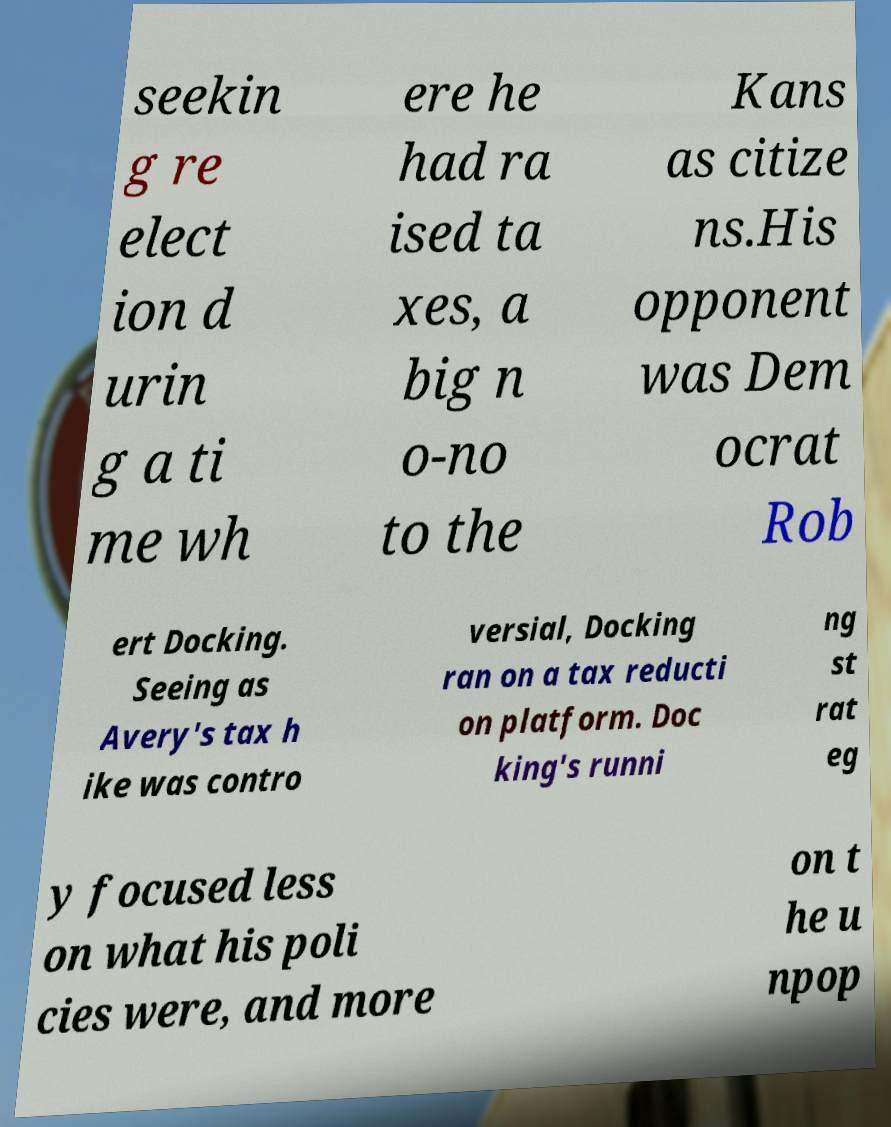Could you assist in decoding the text presented in this image and type it out clearly? seekin g re elect ion d urin g a ti me wh ere he had ra ised ta xes, a big n o-no to the Kans as citize ns.His opponent was Dem ocrat Rob ert Docking. Seeing as Avery's tax h ike was contro versial, Docking ran on a tax reducti on platform. Doc king's runni ng st rat eg y focused less on what his poli cies were, and more on t he u npop 